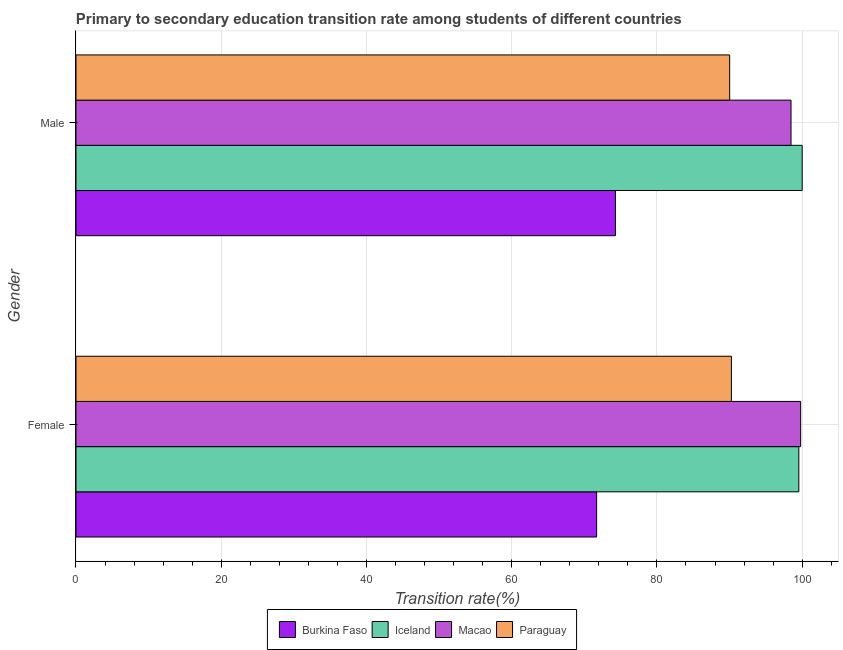How many groups of bars are there?
Your answer should be very brief. 2. Are the number of bars on each tick of the Y-axis equal?
Provide a succinct answer. Yes. How many bars are there on the 2nd tick from the bottom?
Provide a short and direct response. 4. What is the label of the 1st group of bars from the top?
Provide a short and direct response. Male. What is the transition rate among male students in Macao?
Provide a succinct answer. 98.46. Across all countries, what is the maximum transition rate among male students?
Make the answer very short. 100. Across all countries, what is the minimum transition rate among female students?
Your response must be concise. 71.7. In which country was the transition rate among male students maximum?
Your answer should be compact. Iceland. In which country was the transition rate among female students minimum?
Provide a short and direct response. Burkina Faso. What is the total transition rate among female students in the graph?
Provide a succinct answer. 361.28. What is the difference between the transition rate among male students in Iceland and that in Paraguay?
Offer a very short reply. 9.99. What is the difference between the transition rate among female students in Burkina Faso and the transition rate among male students in Iceland?
Your answer should be very brief. -28.3. What is the average transition rate among female students per country?
Offer a very short reply. 90.32. What is the difference between the transition rate among female students and transition rate among male students in Paraguay?
Give a very brief answer. 0.24. What is the ratio of the transition rate among male students in Paraguay to that in Macao?
Give a very brief answer. 0.91. Is the transition rate among female students in Burkina Faso less than that in Paraguay?
Ensure brevity in your answer.  Yes. How many bars are there?
Keep it short and to the point. 8. Are all the bars in the graph horizontal?
Provide a succinct answer. Yes. Are the values on the major ticks of X-axis written in scientific E-notation?
Ensure brevity in your answer.  No. Where does the legend appear in the graph?
Provide a short and direct response. Bottom center. How many legend labels are there?
Your answer should be compact. 4. How are the legend labels stacked?
Offer a terse response. Horizontal. What is the title of the graph?
Your response must be concise. Primary to secondary education transition rate among students of different countries. Does "Brazil" appear as one of the legend labels in the graph?
Give a very brief answer. No. What is the label or title of the X-axis?
Ensure brevity in your answer.  Transition rate(%). What is the Transition rate(%) in Burkina Faso in Female?
Ensure brevity in your answer.  71.7. What is the Transition rate(%) of Iceland in Female?
Your answer should be very brief. 99.54. What is the Transition rate(%) of Macao in Female?
Offer a very short reply. 99.79. What is the Transition rate(%) of Paraguay in Female?
Provide a succinct answer. 90.25. What is the Transition rate(%) in Burkina Faso in Male?
Give a very brief answer. 74.28. What is the Transition rate(%) in Iceland in Male?
Offer a terse response. 100. What is the Transition rate(%) in Macao in Male?
Make the answer very short. 98.46. What is the Transition rate(%) in Paraguay in Male?
Provide a short and direct response. 90.01. Across all Gender, what is the maximum Transition rate(%) of Burkina Faso?
Your answer should be compact. 74.28. Across all Gender, what is the maximum Transition rate(%) of Macao?
Your response must be concise. 99.79. Across all Gender, what is the maximum Transition rate(%) of Paraguay?
Provide a short and direct response. 90.25. Across all Gender, what is the minimum Transition rate(%) of Burkina Faso?
Ensure brevity in your answer.  71.7. Across all Gender, what is the minimum Transition rate(%) in Iceland?
Give a very brief answer. 99.54. Across all Gender, what is the minimum Transition rate(%) of Macao?
Ensure brevity in your answer.  98.46. Across all Gender, what is the minimum Transition rate(%) of Paraguay?
Provide a short and direct response. 90.01. What is the total Transition rate(%) in Burkina Faso in the graph?
Give a very brief answer. 145.98. What is the total Transition rate(%) in Iceland in the graph?
Provide a short and direct response. 199.54. What is the total Transition rate(%) in Macao in the graph?
Your answer should be very brief. 198.25. What is the total Transition rate(%) of Paraguay in the graph?
Offer a very short reply. 180.27. What is the difference between the Transition rate(%) of Burkina Faso in Female and that in Male?
Give a very brief answer. -2.59. What is the difference between the Transition rate(%) of Iceland in Female and that in Male?
Your response must be concise. -0.46. What is the difference between the Transition rate(%) of Macao in Female and that in Male?
Provide a short and direct response. 1.33. What is the difference between the Transition rate(%) of Paraguay in Female and that in Male?
Provide a short and direct response. 0.24. What is the difference between the Transition rate(%) in Burkina Faso in Female and the Transition rate(%) in Iceland in Male?
Offer a terse response. -28.3. What is the difference between the Transition rate(%) of Burkina Faso in Female and the Transition rate(%) of Macao in Male?
Your answer should be very brief. -26.77. What is the difference between the Transition rate(%) of Burkina Faso in Female and the Transition rate(%) of Paraguay in Male?
Offer a very short reply. -18.32. What is the difference between the Transition rate(%) in Iceland in Female and the Transition rate(%) in Macao in Male?
Your answer should be very brief. 1.08. What is the difference between the Transition rate(%) of Iceland in Female and the Transition rate(%) of Paraguay in Male?
Your answer should be very brief. 9.52. What is the difference between the Transition rate(%) in Macao in Female and the Transition rate(%) in Paraguay in Male?
Provide a succinct answer. 9.77. What is the average Transition rate(%) of Burkina Faso per Gender?
Keep it short and to the point. 72.99. What is the average Transition rate(%) in Iceland per Gender?
Provide a short and direct response. 99.77. What is the average Transition rate(%) in Macao per Gender?
Provide a short and direct response. 99.12. What is the average Transition rate(%) in Paraguay per Gender?
Keep it short and to the point. 90.13. What is the difference between the Transition rate(%) in Burkina Faso and Transition rate(%) in Iceland in Female?
Ensure brevity in your answer.  -27.84. What is the difference between the Transition rate(%) of Burkina Faso and Transition rate(%) of Macao in Female?
Make the answer very short. -28.09. What is the difference between the Transition rate(%) of Burkina Faso and Transition rate(%) of Paraguay in Female?
Your answer should be compact. -18.56. What is the difference between the Transition rate(%) in Iceland and Transition rate(%) in Macao in Female?
Your answer should be very brief. -0.25. What is the difference between the Transition rate(%) in Iceland and Transition rate(%) in Paraguay in Female?
Keep it short and to the point. 9.29. What is the difference between the Transition rate(%) in Macao and Transition rate(%) in Paraguay in Female?
Ensure brevity in your answer.  9.54. What is the difference between the Transition rate(%) of Burkina Faso and Transition rate(%) of Iceland in Male?
Your answer should be compact. -25.72. What is the difference between the Transition rate(%) in Burkina Faso and Transition rate(%) in Macao in Male?
Offer a very short reply. -24.18. What is the difference between the Transition rate(%) in Burkina Faso and Transition rate(%) in Paraguay in Male?
Your answer should be compact. -15.73. What is the difference between the Transition rate(%) in Iceland and Transition rate(%) in Macao in Male?
Give a very brief answer. 1.54. What is the difference between the Transition rate(%) of Iceland and Transition rate(%) of Paraguay in Male?
Give a very brief answer. 9.99. What is the difference between the Transition rate(%) in Macao and Transition rate(%) in Paraguay in Male?
Ensure brevity in your answer.  8.45. What is the ratio of the Transition rate(%) of Burkina Faso in Female to that in Male?
Make the answer very short. 0.97. What is the ratio of the Transition rate(%) of Iceland in Female to that in Male?
Offer a very short reply. 1. What is the ratio of the Transition rate(%) in Macao in Female to that in Male?
Make the answer very short. 1.01. What is the difference between the highest and the second highest Transition rate(%) of Burkina Faso?
Give a very brief answer. 2.59. What is the difference between the highest and the second highest Transition rate(%) of Iceland?
Make the answer very short. 0.46. What is the difference between the highest and the second highest Transition rate(%) in Macao?
Give a very brief answer. 1.33. What is the difference between the highest and the second highest Transition rate(%) of Paraguay?
Offer a terse response. 0.24. What is the difference between the highest and the lowest Transition rate(%) in Burkina Faso?
Your response must be concise. 2.59. What is the difference between the highest and the lowest Transition rate(%) of Iceland?
Keep it short and to the point. 0.46. What is the difference between the highest and the lowest Transition rate(%) in Macao?
Keep it short and to the point. 1.33. What is the difference between the highest and the lowest Transition rate(%) of Paraguay?
Your response must be concise. 0.24. 